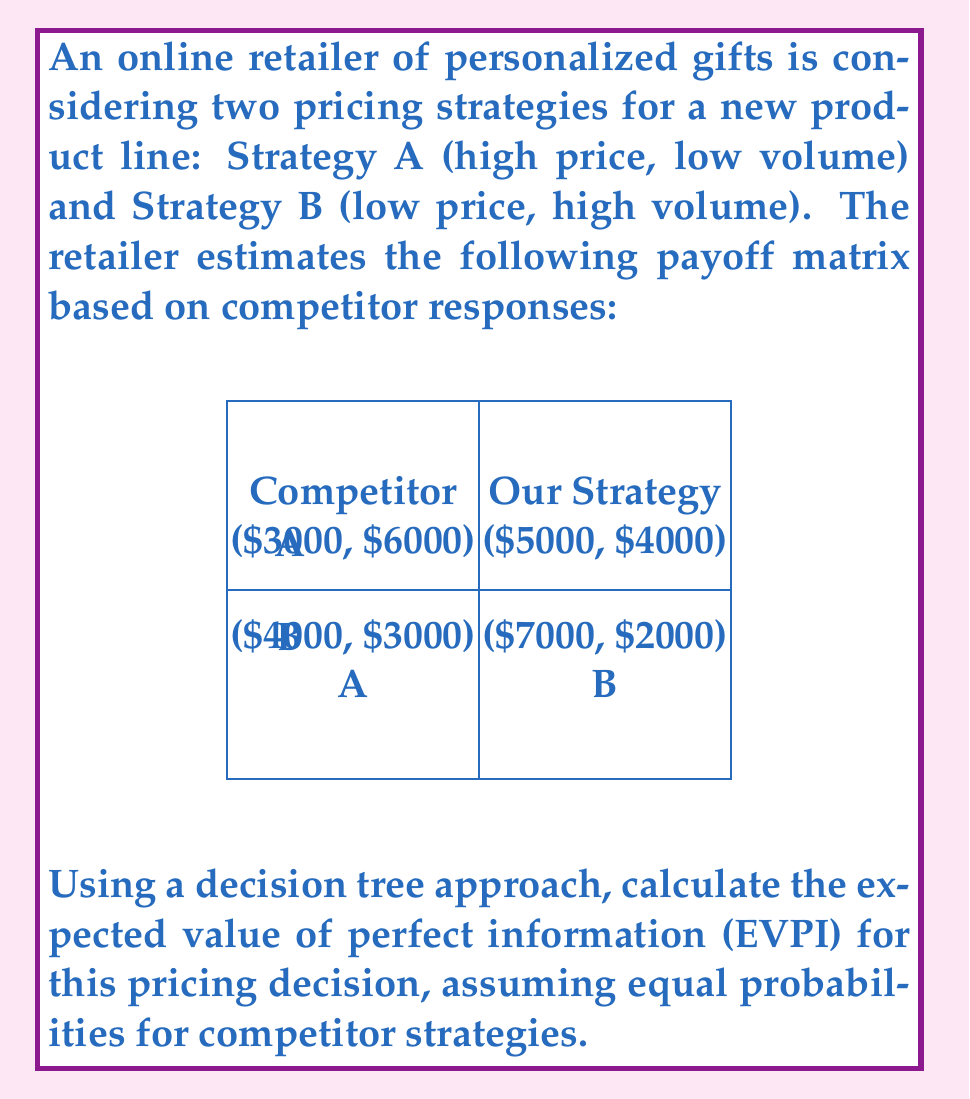Give your solution to this math problem. Let's approach this step-by-step:

1) First, we need to calculate the expected value (EV) of each strategy without perfect information:

   Strategy A: $\frac{1}{2}(3000) + \frac{1}{2}(5000) = 4000$
   Strategy B: $\frac{1}{2}(4000) + \frac{1}{2}(7000) = 5500$

   The optimal strategy without perfect information is B, with an EV of $5500.

2) Now, let's calculate the EV with perfect information:

   If we know the competitor chooses A:
   Our best response is B, yielding $7000.

   If we know the competitor chooses B:
   Our best response is A, yielding $5000.

   The expected value with perfect information is:
   $EV_{PI} = \frac{1}{2}(7000) + \frac{1}{2}(5000) = 6000$

3) The Expected Value of Perfect Information (EVPI) is the difference between the EV with perfect information and the EV of the optimal strategy without perfect information:

   $EVPI = EV_{PI} - EV_{optimal} = 6000 - 5500 = 500$

Thus, the EVPI for this pricing decision is $500.
Answer: $500 